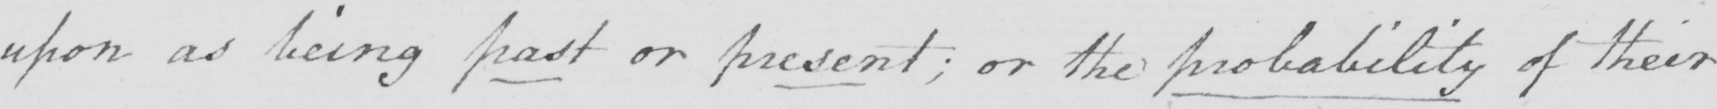What does this handwritten line say? upon as being past or present ; or the probability of their 